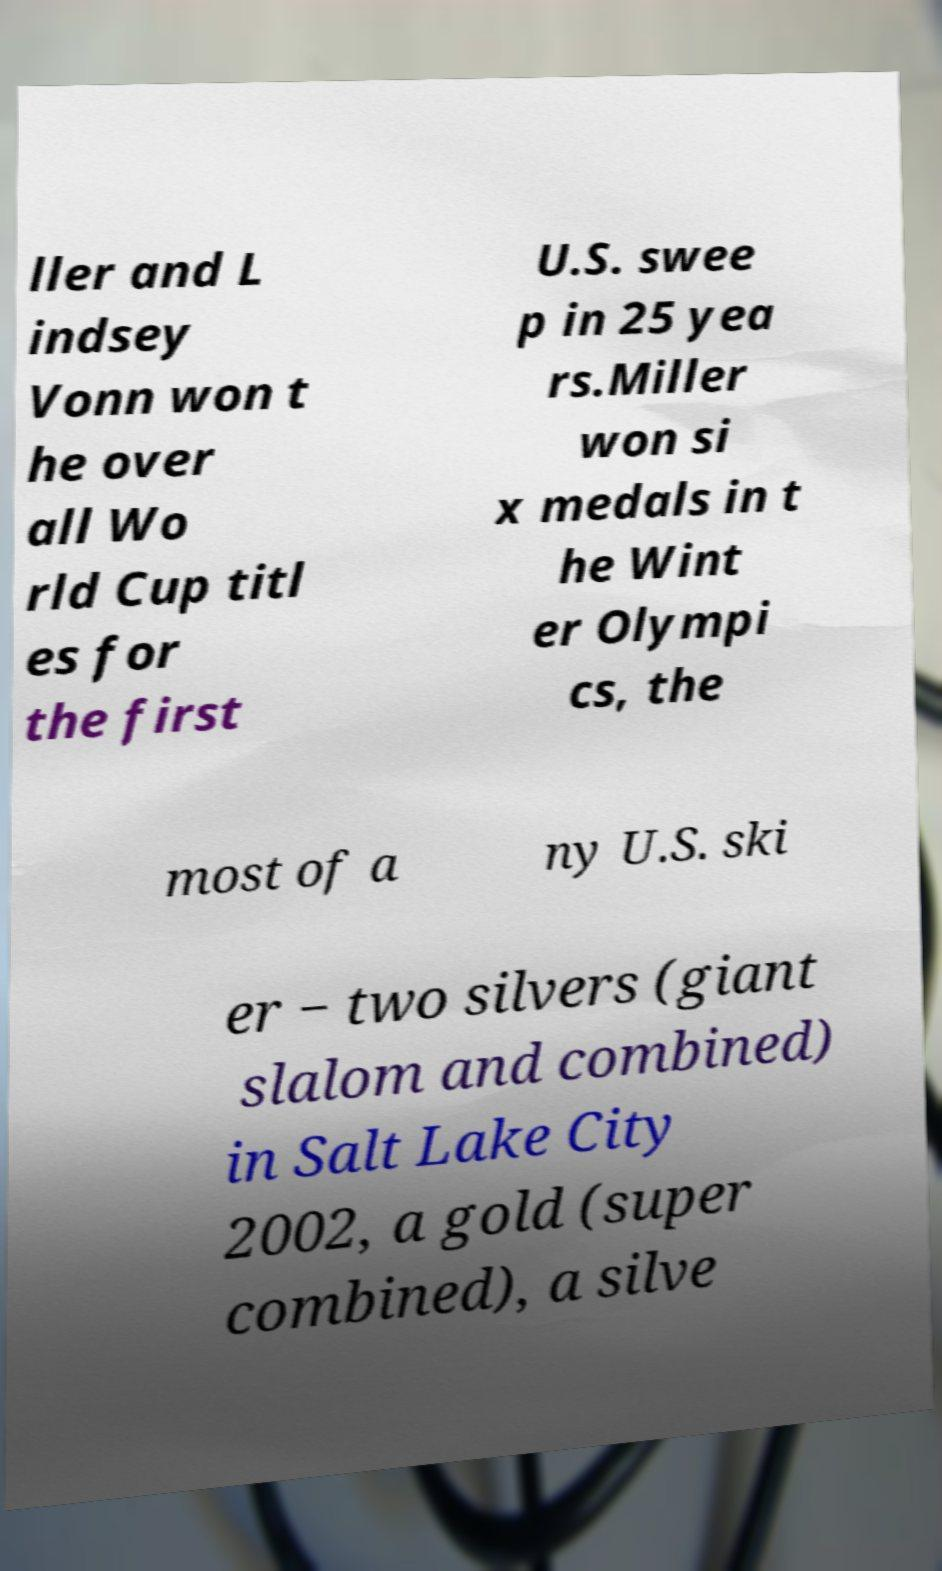For documentation purposes, I need the text within this image transcribed. Could you provide that? ller and L indsey Vonn won t he over all Wo rld Cup titl es for the first U.S. swee p in 25 yea rs.Miller won si x medals in t he Wint er Olympi cs, the most of a ny U.S. ski er − two silvers (giant slalom and combined) in Salt Lake City 2002, a gold (super combined), a silve 